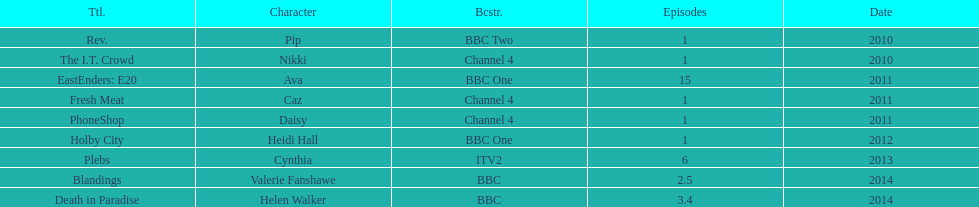In how many shows has sophie colguhoun made an appearance? 9. 